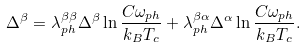<formula> <loc_0><loc_0><loc_500><loc_500>\Delta ^ { \beta } = \lambda _ { p h } ^ { \beta \beta } \Delta ^ { \beta } \ln \frac { C \omega _ { p h } } { k _ { B } T _ { c } } + \lambda _ { p h } ^ { \beta \alpha } \Delta ^ { \alpha } \ln \frac { C \omega _ { p h } } { k _ { B } T _ { c } } .</formula> 